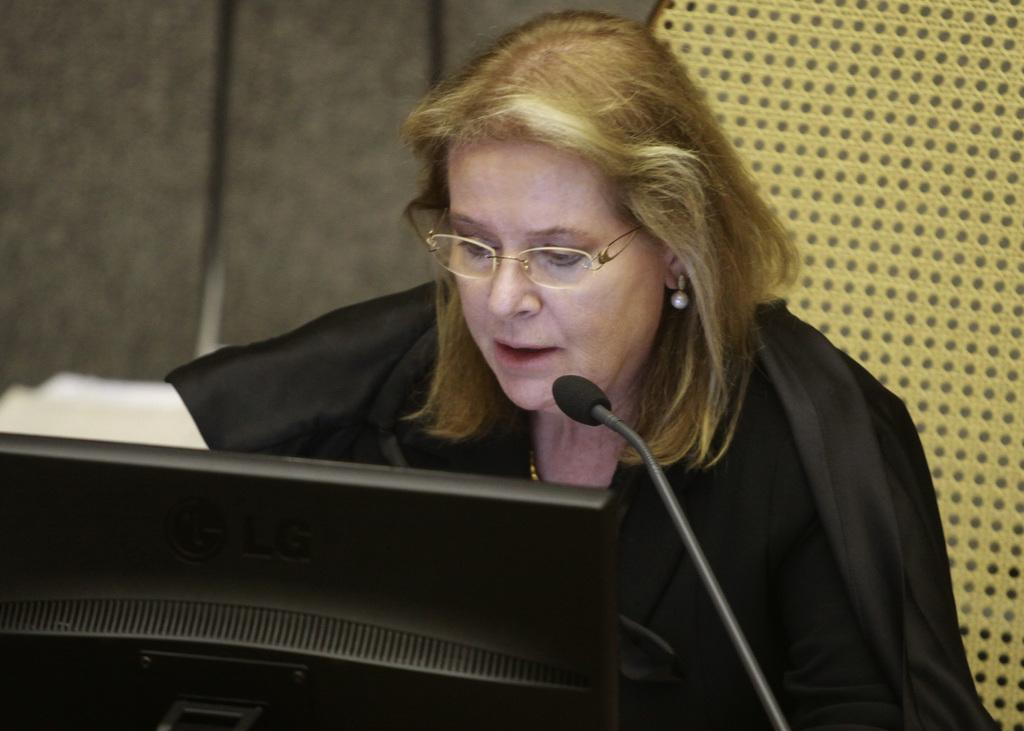Who is the main subject in the image? There is a woman in the image. What is the woman doing in the image? The woman is sitting on a chair and speaking with the help of a microphone. What can be seen on the wall in the background of the image? There is a monitor visible on the wall in the background of the image. What type of condition is the volcano in, as seen in the image? There is no volcano present in the image. What type of plough is being used by the woman in the image? The woman is not using a plough in the image; she is speaking with the help of a microphone. 